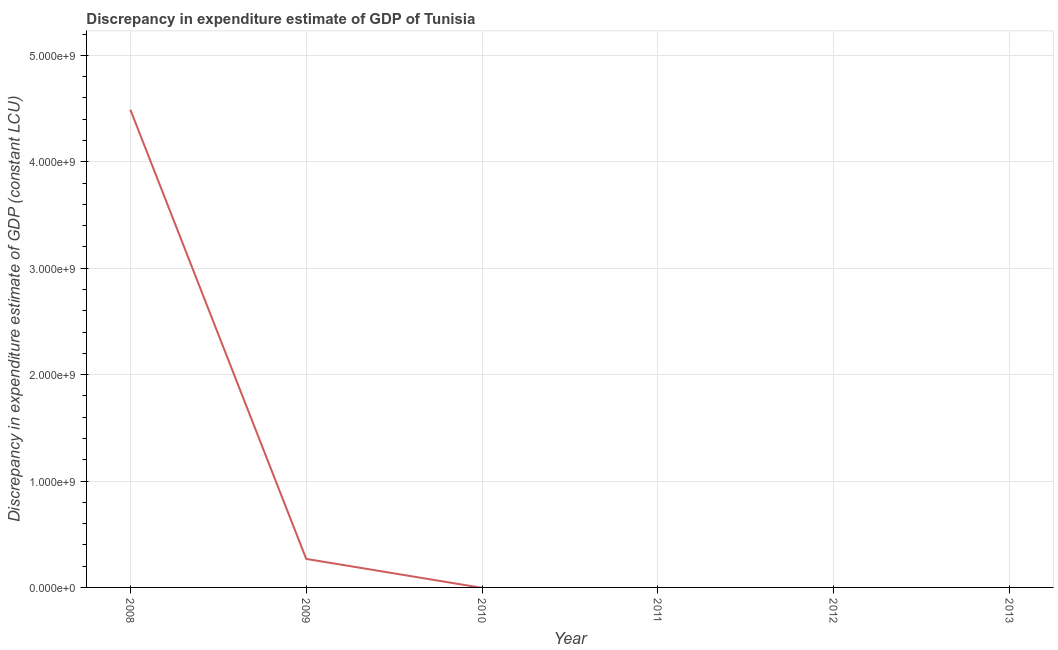What is the discrepancy in expenditure estimate of gdp in 2008?
Ensure brevity in your answer.  4.49e+09. Across all years, what is the maximum discrepancy in expenditure estimate of gdp?
Offer a very short reply. 4.49e+09. Across all years, what is the minimum discrepancy in expenditure estimate of gdp?
Provide a short and direct response. 0. In which year was the discrepancy in expenditure estimate of gdp maximum?
Provide a short and direct response. 2008. What is the sum of the discrepancy in expenditure estimate of gdp?
Provide a succinct answer. 4.76e+09. What is the difference between the discrepancy in expenditure estimate of gdp in 2008 and 2009?
Keep it short and to the point. 4.22e+09. What is the average discrepancy in expenditure estimate of gdp per year?
Give a very brief answer. 7.93e+08. In how many years, is the discrepancy in expenditure estimate of gdp greater than 1400000000 LCU?
Offer a terse response. 1. What is the ratio of the discrepancy in expenditure estimate of gdp in 2008 to that in 2009?
Provide a short and direct response. 16.75. Is the discrepancy in expenditure estimate of gdp in 2008 less than that in 2009?
Offer a terse response. No. What is the difference between the highest and the lowest discrepancy in expenditure estimate of gdp?
Offer a terse response. 4.49e+09. In how many years, is the discrepancy in expenditure estimate of gdp greater than the average discrepancy in expenditure estimate of gdp taken over all years?
Keep it short and to the point. 1. Does the discrepancy in expenditure estimate of gdp monotonically increase over the years?
Make the answer very short. No. How many lines are there?
Offer a terse response. 1. How many years are there in the graph?
Offer a terse response. 6. What is the difference between two consecutive major ticks on the Y-axis?
Offer a very short reply. 1.00e+09. Are the values on the major ticks of Y-axis written in scientific E-notation?
Offer a terse response. Yes. Does the graph contain any zero values?
Offer a terse response. Yes. Does the graph contain grids?
Ensure brevity in your answer.  Yes. What is the title of the graph?
Make the answer very short. Discrepancy in expenditure estimate of GDP of Tunisia. What is the label or title of the Y-axis?
Give a very brief answer. Discrepancy in expenditure estimate of GDP (constant LCU). What is the Discrepancy in expenditure estimate of GDP (constant LCU) in 2008?
Provide a succinct answer. 4.49e+09. What is the Discrepancy in expenditure estimate of GDP (constant LCU) of 2009?
Ensure brevity in your answer.  2.68e+08. What is the Discrepancy in expenditure estimate of GDP (constant LCU) of 2011?
Offer a terse response. 0. What is the difference between the Discrepancy in expenditure estimate of GDP (constant LCU) in 2008 and 2009?
Ensure brevity in your answer.  4.22e+09. What is the ratio of the Discrepancy in expenditure estimate of GDP (constant LCU) in 2008 to that in 2009?
Offer a terse response. 16.75. 